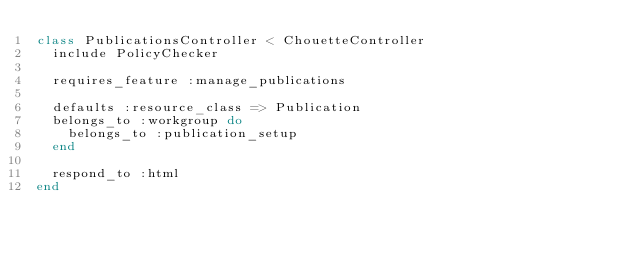Convert code to text. <code><loc_0><loc_0><loc_500><loc_500><_Ruby_>class PublicationsController < ChouetteController
  include PolicyChecker

  requires_feature :manage_publications

  defaults :resource_class => Publication
  belongs_to :workgroup do
    belongs_to :publication_setup
  end

  respond_to :html
end
</code> 